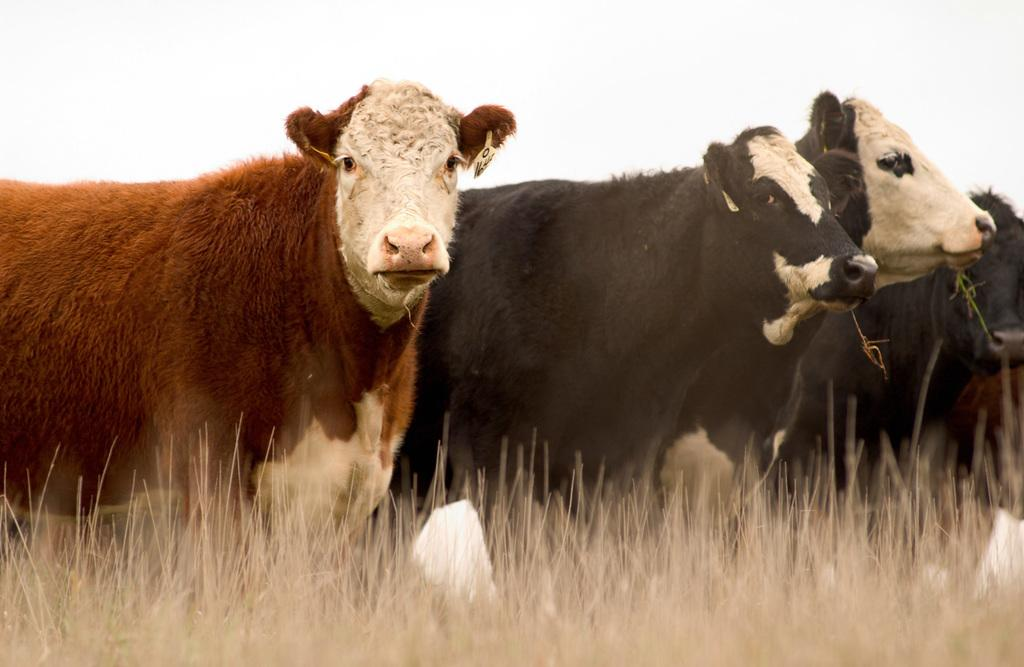What type of vegetation is present in the image? There is grass in the image. What animals can be seen in the middle of the image? There are cows in the middle of the image. What is visible at the top of the image? The sky is visible at the top of the image. How many trees are present in the cemetery in the image? There is no cemetery or tree present in the image; it features grass and cows. What is the source of hope in the image? The image does not depict a source of hope, as it only shows grass, cows, and the sky. 